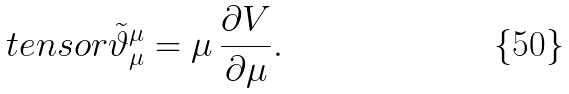Convert formula to latex. <formula><loc_0><loc_0><loc_500><loc_500>\ t e n s o r { \tilde { \vartheta } } { _ { \mu } ^ { \mu } } = \mu \, \frac { \partial V } { \partial \mu } .</formula> 